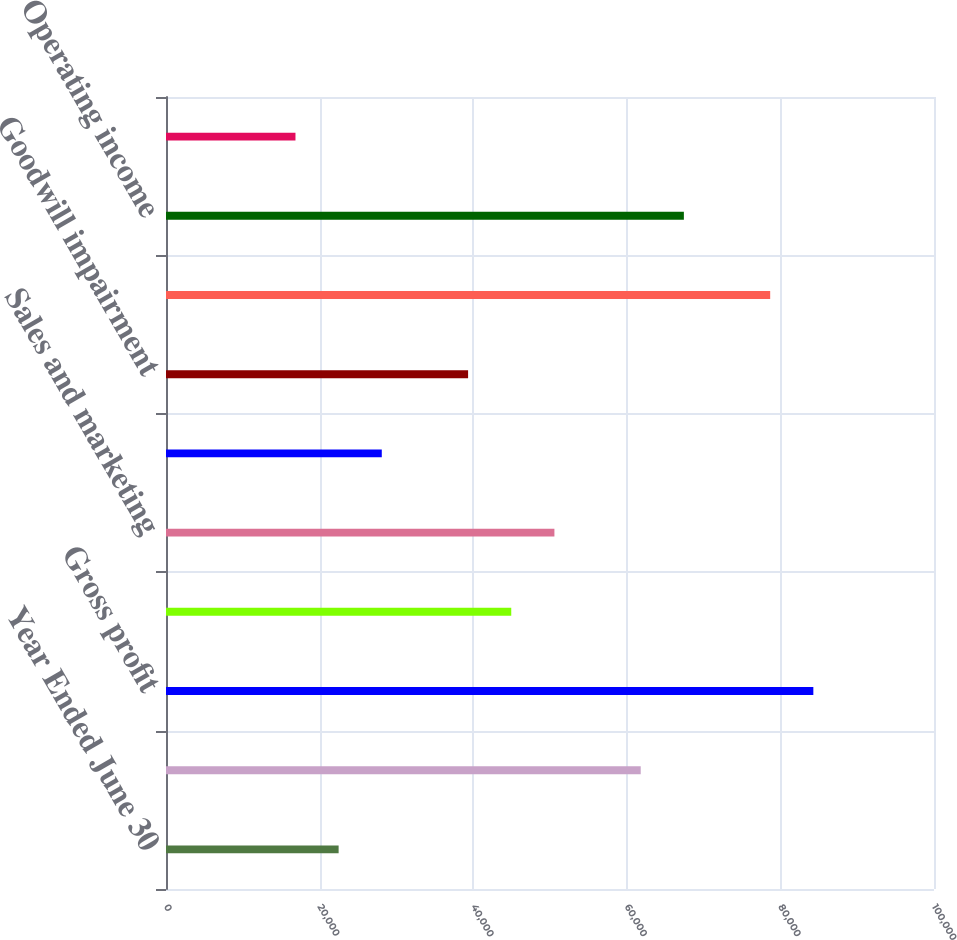Convert chart. <chart><loc_0><loc_0><loc_500><loc_500><bar_chart><fcel>Year Ended June 30<fcel>Cost of revenue<fcel>Gross profit<fcel>Research and development<fcel>Sales and marketing<fcel>General and administrative<fcel>Goodwill impairment<fcel>Total operating expenses<fcel>Operating income<fcel>Other income<nl><fcel>22477.7<fcel>61812.2<fcel>84289.1<fcel>44954.6<fcel>50573.8<fcel>28096.9<fcel>39335.3<fcel>78669.9<fcel>67431.4<fcel>16858.5<nl></chart> 